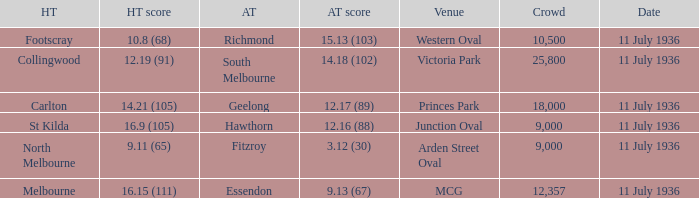What Away team got a team score of 12.16 (88)? Hawthorn. 